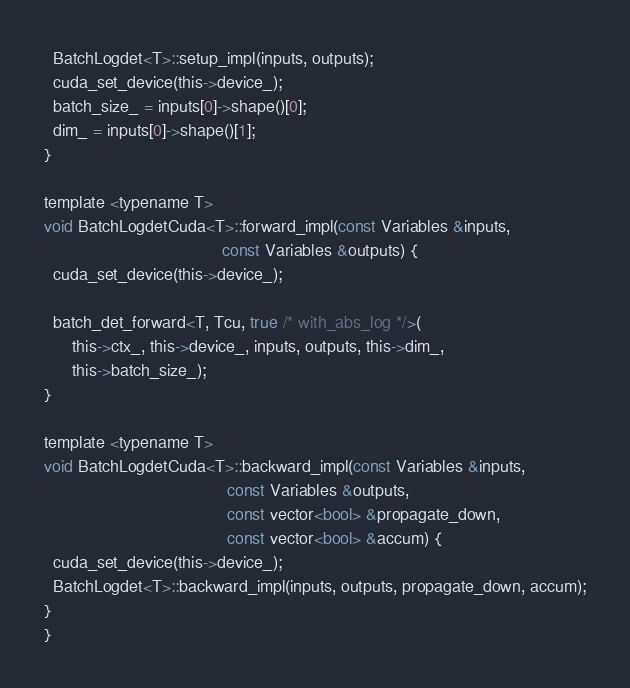Convert code to text. <code><loc_0><loc_0><loc_500><loc_500><_Cuda_>  BatchLogdet<T>::setup_impl(inputs, outputs);
  cuda_set_device(this->device_);
  batch_size_ = inputs[0]->shape()[0];
  dim_ = inputs[0]->shape()[1];
}

template <typename T>
void BatchLogdetCuda<T>::forward_impl(const Variables &inputs,
                                      const Variables &outputs) {
  cuda_set_device(this->device_);

  batch_det_forward<T, Tcu, true /* with_abs_log */>(
      this->ctx_, this->device_, inputs, outputs, this->dim_,
      this->batch_size_);
}

template <typename T>
void BatchLogdetCuda<T>::backward_impl(const Variables &inputs,
                                       const Variables &outputs,
                                       const vector<bool> &propagate_down,
                                       const vector<bool> &accum) {
  cuda_set_device(this->device_);
  BatchLogdet<T>::backward_impl(inputs, outputs, propagate_down, accum);
}
}
</code> 